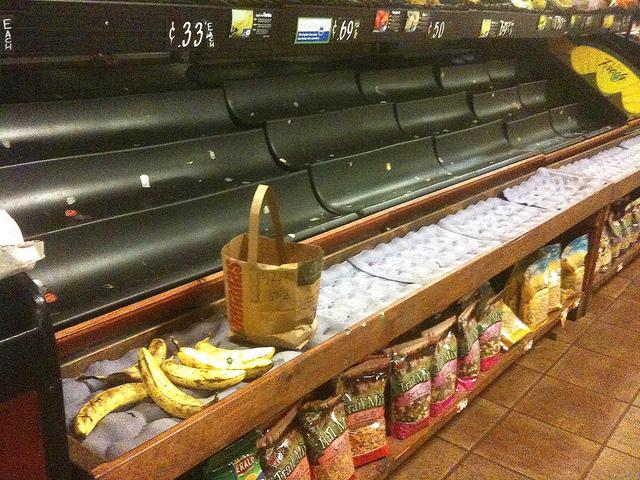What fruit is being sold?
Be succinct. Bananas. Is this a grocery store?
Concise answer only. Yes. What would normally be covering the black shelves?
Quick response, please. Bananas. 